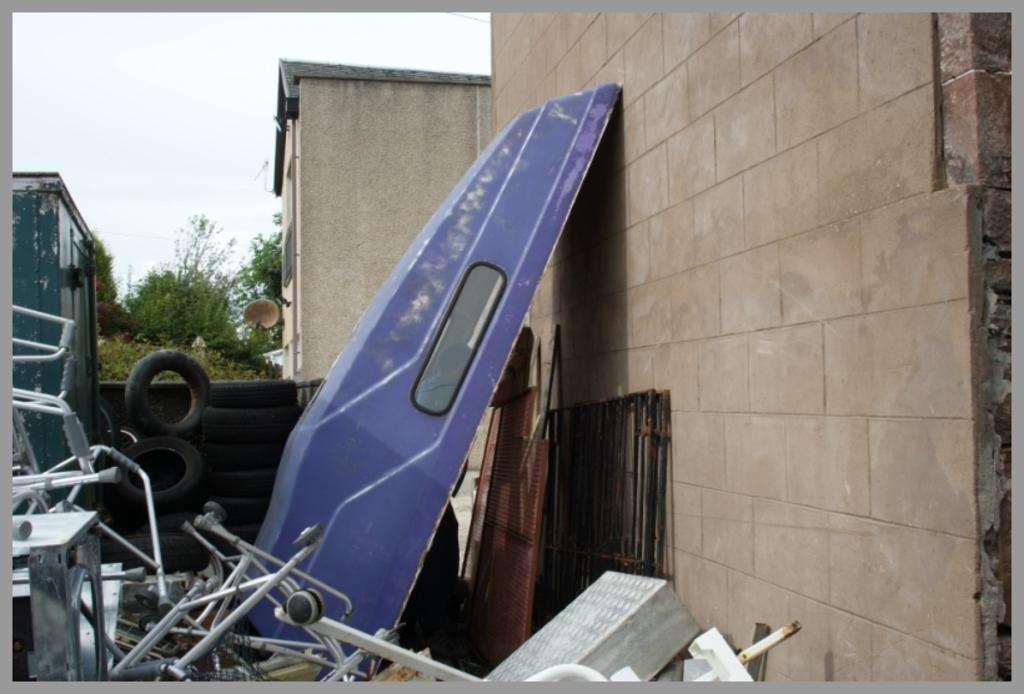Could you give a brief overview of what you see in this image? In this picture we can see some spare parts are placed beside the wall. 